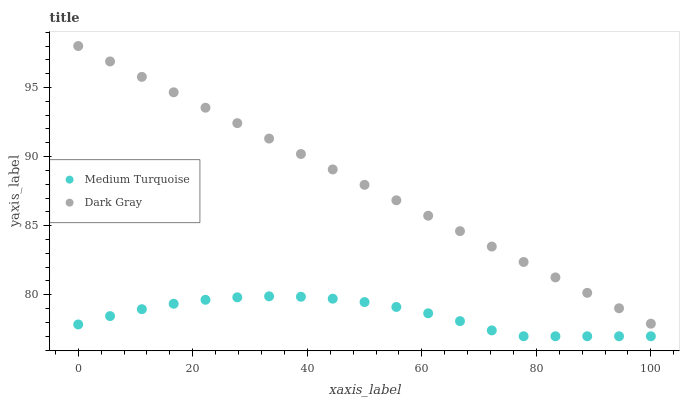Does Medium Turquoise have the minimum area under the curve?
Answer yes or no. Yes. Does Dark Gray have the maximum area under the curve?
Answer yes or no. Yes. Does Medium Turquoise have the maximum area under the curve?
Answer yes or no. No. Is Dark Gray the smoothest?
Answer yes or no. Yes. Is Medium Turquoise the roughest?
Answer yes or no. Yes. Is Medium Turquoise the smoothest?
Answer yes or no. No. Does Medium Turquoise have the lowest value?
Answer yes or no. Yes. Does Dark Gray have the highest value?
Answer yes or no. Yes. Does Medium Turquoise have the highest value?
Answer yes or no. No. Is Medium Turquoise less than Dark Gray?
Answer yes or no. Yes. Is Dark Gray greater than Medium Turquoise?
Answer yes or no. Yes. Does Medium Turquoise intersect Dark Gray?
Answer yes or no. No. 